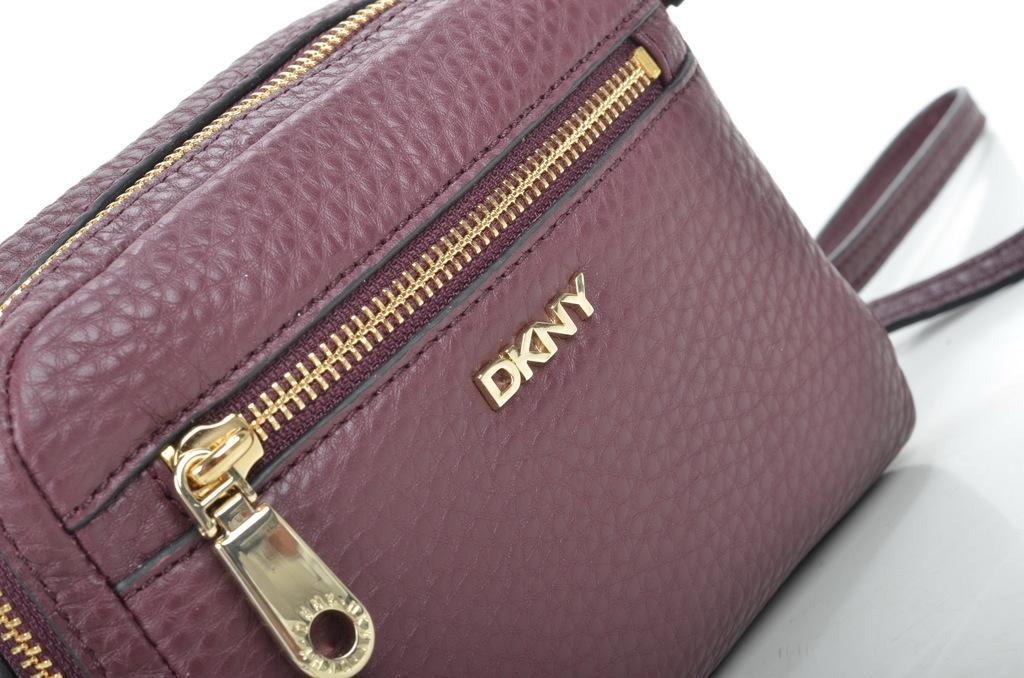Can you describe this image briefly? This is the picture of a bag in purple color where the zip is in golden color and it is written dkny on it. 